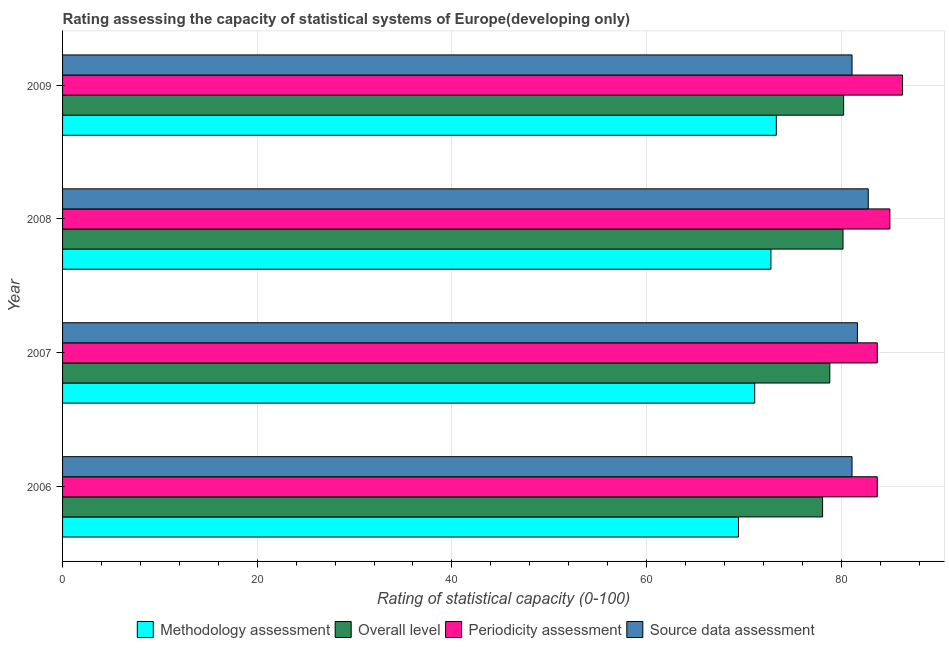How many groups of bars are there?
Keep it short and to the point. 4. How many bars are there on the 2nd tick from the top?
Your answer should be very brief. 4. How many bars are there on the 3rd tick from the bottom?
Provide a short and direct response. 4. What is the overall level rating in 2006?
Make the answer very short. 78.09. Across all years, what is the maximum periodicity assessment rating?
Your response must be concise. 86.3. Across all years, what is the minimum periodicity assessment rating?
Offer a terse response. 83.7. In which year was the source data assessment rating minimum?
Give a very brief answer. 2006. What is the total source data assessment rating in the graph?
Your response must be concise. 326.67. What is the difference between the periodicity assessment rating in 2008 and that in 2009?
Offer a very short reply. -1.3. What is the difference between the periodicity assessment rating in 2009 and the source data assessment rating in 2007?
Your answer should be very brief. 4.63. What is the average source data assessment rating per year?
Offer a very short reply. 81.67. In the year 2009, what is the difference between the methodology assessment rating and periodicity assessment rating?
Ensure brevity in your answer.  -12.96. What is the ratio of the periodicity assessment rating in 2006 to that in 2007?
Offer a very short reply. 1. Is the source data assessment rating in 2006 less than that in 2008?
Provide a succinct answer. Yes. Is the difference between the periodicity assessment rating in 2006 and 2007 greater than the difference between the overall level rating in 2006 and 2007?
Your answer should be very brief. Yes. What is the difference between the highest and the second highest source data assessment rating?
Provide a succinct answer. 1.11. What is the difference between the highest and the lowest periodicity assessment rating?
Provide a succinct answer. 2.59. Is the sum of the periodicity assessment rating in 2006 and 2009 greater than the maximum source data assessment rating across all years?
Keep it short and to the point. Yes. Is it the case that in every year, the sum of the periodicity assessment rating and source data assessment rating is greater than the sum of overall level rating and methodology assessment rating?
Provide a short and direct response. Yes. What does the 2nd bar from the top in 2009 represents?
Give a very brief answer. Periodicity assessment. What does the 2nd bar from the bottom in 2008 represents?
Give a very brief answer. Overall level. Is it the case that in every year, the sum of the methodology assessment rating and overall level rating is greater than the periodicity assessment rating?
Ensure brevity in your answer.  Yes. How many years are there in the graph?
Provide a short and direct response. 4. Are the values on the major ticks of X-axis written in scientific E-notation?
Provide a short and direct response. No. How many legend labels are there?
Keep it short and to the point. 4. What is the title of the graph?
Offer a terse response. Rating assessing the capacity of statistical systems of Europe(developing only). Does "UNTA" appear as one of the legend labels in the graph?
Offer a terse response. No. What is the label or title of the X-axis?
Give a very brief answer. Rating of statistical capacity (0-100). What is the label or title of the Y-axis?
Provide a succinct answer. Year. What is the Rating of statistical capacity (0-100) of Methodology assessment in 2006?
Your answer should be compact. 69.44. What is the Rating of statistical capacity (0-100) in Overall level in 2006?
Your response must be concise. 78.09. What is the Rating of statistical capacity (0-100) of Periodicity assessment in 2006?
Ensure brevity in your answer.  83.7. What is the Rating of statistical capacity (0-100) in Source data assessment in 2006?
Provide a short and direct response. 81.11. What is the Rating of statistical capacity (0-100) of Methodology assessment in 2007?
Give a very brief answer. 71.11. What is the Rating of statistical capacity (0-100) of Overall level in 2007?
Give a very brief answer. 78.83. What is the Rating of statistical capacity (0-100) in Periodicity assessment in 2007?
Ensure brevity in your answer.  83.7. What is the Rating of statistical capacity (0-100) of Source data assessment in 2007?
Offer a terse response. 81.67. What is the Rating of statistical capacity (0-100) in Methodology assessment in 2008?
Offer a terse response. 72.78. What is the Rating of statistical capacity (0-100) in Overall level in 2008?
Your answer should be compact. 80.19. What is the Rating of statistical capacity (0-100) of Periodicity assessment in 2008?
Give a very brief answer. 85. What is the Rating of statistical capacity (0-100) in Source data assessment in 2008?
Keep it short and to the point. 82.78. What is the Rating of statistical capacity (0-100) of Methodology assessment in 2009?
Your answer should be compact. 73.33. What is the Rating of statistical capacity (0-100) in Overall level in 2009?
Make the answer very short. 80.25. What is the Rating of statistical capacity (0-100) in Periodicity assessment in 2009?
Provide a succinct answer. 86.3. What is the Rating of statistical capacity (0-100) in Source data assessment in 2009?
Keep it short and to the point. 81.11. Across all years, what is the maximum Rating of statistical capacity (0-100) in Methodology assessment?
Give a very brief answer. 73.33. Across all years, what is the maximum Rating of statistical capacity (0-100) of Overall level?
Keep it short and to the point. 80.25. Across all years, what is the maximum Rating of statistical capacity (0-100) of Periodicity assessment?
Give a very brief answer. 86.3. Across all years, what is the maximum Rating of statistical capacity (0-100) in Source data assessment?
Keep it short and to the point. 82.78. Across all years, what is the minimum Rating of statistical capacity (0-100) of Methodology assessment?
Provide a succinct answer. 69.44. Across all years, what is the minimum Rating of statistical capacity (0-100) of Overall level?
Your answer should be compact. 78.09. Across all years, what is the minimum Rating of statistical capacity (0-100) of Periodicity assessment?
Offer a very short reply. 83.7. Across all years, what is the minimum Rating of statistical capacity (0-100) in Source data assessment?
Your answer should be very brief. 81.11. What is the total Rating of statistical capacity (0-100) of Methodology assessment in the graph?
Offer a terse response. 286.67. What is the total Rating of statistical capacity (0-100) of Overall level in the graph?
Offer a terse response. 317.35. What is the total Rating of statistical capacity (0-100) in Periodicity assessment in the graph?
Make the answer very short. 338.7. What is the total Rating of statistical capacity (0-100) of Source data assessment in the graph?
Make the answer very short. 326.67. What is the difference between the Rating of statistical capacity (0-100) in Methodology assessment in 2006 and that in 2007?
Provide a short and direct response. -1.67. What is the difference between the Rating of statistical capacity (0-100) of Overall level in 2006 and that in 2007?
Give a very brief answer. -0.74. What is the difference between the Rating of statistical capacity (0-100) of Source data assessment in 2006 and that in 2007?
Ensure brevity in your answer.  -0.56. What is the difference between the Rating of statistical capacity (0-100) of Overall level in 2006 and that in 2008?
Make the answer very short. -2.1. What is the difference between the Rating of statistical capacity (0-100) of Periodicity assessment in 2006 and that in 2008?
Your answer should be compact. -1.3. What is the difference between the Rating of statistical capacity (0-100) of Source data assessment in 2006 and that in 2008?
Make the answer very short. -1.67. What is the difference between the Rating of statistical capacity (0-100) in Methodology assessment in 2006 and that in 2009?
Give a very brief answer. -3.89. What is the difference between the Rating of statistical capacity (0-100) of Overall level in 2006 and that in 2009?
Your answer should be very brief. -2.16. What is the difference between the Rating of statistical capacity (0-100) of Periodicity assessment in 2006 and that in 2009?
Make the answer very short. -2.59. What is the difference between the Rating of statistical capacity (0-100) in Source data assessment in 2006 and that in 2009?
Your response must be concise. 0. What is the difference between the Rating of statistical capacity (0-100) of Methodology assessment in 2007 and that in 2008?
Offer a very short reply. -1.67. What is the difference between the Rating of statistical capacity (0-100) of Overall level in 2007 and that in 2008?
Ensure brevity in your answer.  -1.36. What is the difference between the Rating of statistical capacity (0-100) of Periodicity assessment in 2007 and that in 2008?
Keep it short and to the point. -1.3. What is the difference between the Rating of statistical capacity (0-100) in Source data assessment in 2007 and that in 2008?
Offer a terse response. -1.11. What is the difference between the Rating of statistical capacity (0-100) of Methodology assessment in 2007 and that in 2009?
Your response must be concise. -2.22. What is the difference between the Rating of statistical capacity (0-100) in Overall level in 2007 and that in 2009?
Offer a terse response. -1.42. What is the difference between the Rating of statistical capacity (0-100) of Periodicity assessment in 2007 and that in 2009?
Your response must be concise. -2.59. What is the difference between the Rating of statistical capacity (0-100) in Source data assessment in 2007 and that in 2009?
Give a very brief answer. 0.56. What is the difference between the Rating of statistical capacity (0-100) in Methodology assessment in 2008 and that in 2009?
Your answer should be very brief. -0.56. What is the difference between the Rating of statistical capacity (0-100) in Overall level in 2008 and that in 2009?
Offer a very short reply. -0.06. What is the difference between the Rating of statistical capacity (0-100) of Periodicity assessment in 2008 and that in 2009?
Provide a short and direct response. -1.3. What is the difference between the Rating of statistical capacity (0-100) in Source data assessment in 2008 and that in 2009?
Offer a very short reply. 1.67. What is the difference between the Rating of statistical capacity (0-100) in Methodology assessment in 2006 and the Rating of statistical capacity (0-100) in Overall level in 2007?
Give a very brief answer. -9.38. What is the difference between the Rating of statistical capacity (0-100) of Methodology assessment in 2006 and the Rating of statistical capacity (0-100) of Periodicity assessment in 2007?
Your response must be concise. -14.26. What is the difference between the Rating of statistical capacity (0-100) in Methodology assessment in 2006 and the Rating of statistical capacity (0-100) in Source data assessment in 2007?
Give a very brief answer. -12.22. What is the difference between the Rating of statistical capacity (0-100) in Overall level in 2006 and the Rating of statistical capacity (0-100) in Periodicity assessment in 2007?
Your answer should be very brief. -5.62. What is the difference between the Rating of statistical capacity (0-100) of Overall level in 2006 and the Rating of statistical capacity (0-100) of Source data assessment in 2007?
Ensure brevity in your answer.  -3.58. What is the difference between the Rating of statistical capacity (0-100) of Periodicity assessment in 2006 and the Rating of statistical capacity (0-100) of Source data assessment in 2007?
Ensure brevity in your answer.  2.04. What is the difference between the Rating of statistical capacity (0-100) in Methodology assessment in 2006 and the Rating of statistical capacity (0-100) in Overall level in 2008?
Keep it short and to the point. -10.74. What is the difference between the Rating of statistical capacity (0-100) in Methodology assessment in 2006 and the Rating of statistical capacity (0-100) in Periodicity assessment in 2008?
Provide a short and direct response. -15.56. What is the difference between the Rating of statistical capacity (0-100) of Methodology assessment in 2006 and the Rating of statistical capacity (0-100) of Source data assessment in 2008?
Ensure brevity in your answer.  -13.33. What is the difference between the Rating of statistical capacity (0-100) of Overall level in 2006 and the Rating of statistical capacity (0-100) of Periodicity assessment in 2008?
Your response must be concise. -6.91. What is the difference between the Rating of statistical capacity (0-100) of Overall level in 2006 and the Rating of statistical capacity (0-100) of Source data assessment in 2008?
Give a very brief answer. -4.69. What is the difference between the Rating of statistical capacity (0-100) of Periodicity assessment in 2006 and the Rating of statistical capacity (0-100) of Source data assessment in 2008?
Provide a short and direct response. 0.93. What is the difference between the Rating of statistical capacity (0-100) of Methodology assessment in 2006 and the Rating of statistical capacity (0-100) of Overall level in 2009?
Your answer should be very brief. -10.8. What is the difference between the Rating of statistical capacity (0-100) of Methodology assessment in 2006 and the Rating of statistical capacity (0-100) of Periodicity assessment in 2009?
Ensure brevity in your answer.  -16.85. What is the difference between the Rating of statistical capacity (0-100) of Methodology assessment in 2006 and the Rating of statistical capacity (0-100) of Source data assessment in 2009?
Provide a short and direct response. -11.67. What is the difference between the Rating of statistical capacity (0-100) of Overall level in 2006 and the Rating of statistical capacity (0-100) of Periodicity assessment in 2009?
Your answer should be very brief. -8.21. What is the difference between the Rating of statistical capacity (0-100) of Overall level in 2006 and the Rating of statistical capacity (0-100) of Source data assessment in 2009?
Offer a terse response. -3.02. What is the difference between the Rating of statistical capacity (0-100) of Periodicity assessment in 2006 and the Rating of statistical capacity (0-100) of Source data assessment in 2009?
Make the answer very short. 2.59. What is the difference between the Rating of statistical capacity (0-100) in Methodology assessment in 2007 and the Rating of statistical capacity (0-100) in Overall level in 2008?
Your answer should be very brief. -9.07. What is the difference between the Rating of statistical capacity (0-100) in Methodology assessment in 2007 and the Rating of statistical capacity (0-100) in Periodicity assessment in 2008?
Give a very brief answer. -13.89. What is the difference between the Rating of statistical capacity (0-100) in Methodology assessment in 2007 and the Rating of statistical capacity (0-100) in Source data assessment in 2008?
Your answer should be compact. -11.67. What is the difference between the Rating of statistical capacity (0-100) in Overall level in 2007 and the Rating of statistical capacity (0-100) in Periodicity assessment in 2008?
Your answer should be very brief. -6.17. What is the difference between the Rating of statistical capacity (0-100) in Overall level in 2007 and the Rating of statistical capacity (0-100) in Source data assessment in 2008?
Your answer should be very brief. -3.95. What is the difference between the Rating of statistical capacity (0-100) of Periodicity assessment in 2007 and the Rating of statistical capacity (0-100) of Source data assessment in 2008?
Provide a short and direct response. 0.93. What is the difference between the Rating of statistical capacity (0-100) of Methodology assessment in 2007 and the Rating of statistical capacity (0-100) of Overall level in 2009?
Your answer should be very brief. -9.14. What is the difference between the Rating of statistical capacity (0-100) in Methodology assessment in 2007 and the Rating of statistical capacity (0-100) in Periodicity assessment in 2009?
Provide a succinct answer. -15.18. What is the difference between the Rating of statistical capacity (0-100) of Overall level in 2007 and the Rating of statistical capacity (0-100) of Periodicity assessment in 2009?
Make the answer very short. -7.47. What is the difference between the Rating of statistical capacity (0-100) in Overall level in 2007 and the Rating of statistical capacity (0-100) in Source data assessment in 2009?
Provide a short and direct response. -2.28. What is the difference between the Rating of statistical capacity (0-100) in Periodicity assessment in 2007 and the Rating of statistical capacity (0-100) in Source data assessment in 2009?
Offer a very short reply. 2.59. What is the difference between the Rating of statistical capacity (0-100) of Methodology assessment in 2008 and the Rating of statistical capacity (0-100) of Overall level in 2009?
Keep it short and to the point. -7.47. What is the difference between the Rating of statistical capacity (0-100) of Methodology assessment in 2008 and the Rating of statistical capacity (0-100) of Periodicity assessment in 2009?
Provide a succinct answer. -13.52. What is the difference between the Rating of statistical capacity (0-100) in Methodology assessment in 2008 and the Rating of statistical capacity (0-100) in Source data assessment in 2009?
Your answer should be very brief. -8.33. What is the difference between the Rating of statistical capacity (0-100) in Overall level in 2008 and the Rating of statistical capacity (0-100) in Periodicity assessment in 2009?
Ensure brevity in your answer.  -6.11. What is the difference between the Rating of statistical capacity (0-100) of Overall level in 2008 and the Rating of statistical capacity (0-100) of Source data assessment in 2009?
Ensure brevity in your answer.  -0.93. What is the difference between the Rating of statistical capacity (0-100) of Periodicity assessment in 2008 and the Rating of statistical capacity (0-100) of Source data assessment in 2009?
Provide a succinct answer. 3.89. What is the average Rating of statistical capacity (0-100) in Methodology assessment per year?
Make the answer very short. 71.67. What is the average Rating of statistical capacity (0-100) in Overall level per year?
Make the answer very short. 79.34. What is the average Rating of statistical capacity (0-100) in Periodicity assessment per year?
Give a very brief answer. 84.68. What is the average Rating of statistical capacity (0-100) in Source data assessment per year?
Ensure brevity in your answer.  81.67. In the year 2006, what is the difference between the Rating of statistical capacity (0-100) in Methodology assessment and Rating of statistical capacity (0-100) in Overall level?
Your answer should be compact. -8.64. In the year 2006, what is the difference between the Rating of statistical capacity (0-100) of Methodology assessment and Rating of statistical capacity (0-100) of Periodicity assessment?
Ensure brevity in your answer.  -14.26. In the year 2006, what is the difference between the Rating of statistical capacity (0-100) in Methodology assessment and Rating of statistical capacity (0-100) in Source data assessment?
Provide a short and direct response. -11.67. In the year 2006, what is the difference between the Rating of statistical capacity (0-100) of Overall level and Rating of statistical capacity (0-100) of Periodicity assessment?
Give a very brief answer. -5.62. In the year 2006, what is the difference between the Rating of statistical capacity (0-100) in Overall level and Rating of statistical capacity (0-100) in Source data assessment?
Keep it short and to the point. -3.02. In the year 2006, what is the difference between the Rating of statistical capacity (0-100) in Periodicity assessment and Rating of statistical capacity (0-100) in Source data assessment?
Keep it short and to the point. 2.59. In the year 2007, what is the difference between the Rating of statistical capacity (0-100) in Methodology assessment and Rating of statistical capacity (0-100) in Overall level?
Your answer should be very brief. -7.72. In the year 2007, what is the difference between the Rating of statistical capacity (0-100) of Methodology assessment and Rating of statistical capacity (0-100) of Periodicity assessment?
Your answer should be compact. -12.59. In the year 2007, what is the difference between the Rating of statistical capacity (0-100) in Methodology assessment and Rating of statistical capacity (0-100) in Source data assessment?
Provide a short and direct response. -10.56. In the year 2007, what is the difference between the Rating of statistical capacity (0-100) in Overall level and Rating of statistical capacity (0-100) in Periodicity assessment?
Your answer should be very brief. -4.88. In the year 2007, what is the difference between the Rating of statistical capacity (0-100) in Overall level and Rating of statistical capacity (0-100) in Source data assessment?
Your answer should be very brief. -2.84. In the year 2007, what is the difference between the Rating of statistical capacity (0-100) in Periodicity assessment and Rating of statistical capacity (0-100) in Source data assessment?
Provide a succinct answer. 2.04. In the year 2008, what is the difference between the Rating of statistical capacity (0-100) in Methodology assessment and Rating of statistical capacity (0-100) in Overall level?
Your answer should be very brief. -7.41. In the year 2008, what is the difference between the Rating of statistical capacity (0-100) of Methodology assessment and Rating of statistical capacity (0-100) of Periodicity assessment?
Your answer should be compact. -12.22. In the year 2008, what is the difference between the Rating of statistical capacity (0-100) in Methodology assessment and Rating of statistical capacity (0-100) in Source data assessment?
Ensure brevity in your answer.  -10. In the year 2008, what is the difference between the Rating of statistical capacity (0-100) of Overall level and Rating of statistical capacity (0-100) of Periodicity assessment?
Offer a terse response. -4.81. In the year 2008, what is the difference between the Rating of statistical capacity (0-100) of Overall level and Rating of statistical capacity (0-100) of Source data assessment?
Ensure brevity in your answer.  -2.59. In the year 2008, what is the difference between the Rating of statistical capacity (0-100) of Periodicity assessment and Rating of statistical capacity (0-100) of Source data assessment?
Give a very brief answer. 2.22. In the year 2009, what is the difference between the Rating of statistical capacity (0-100) of Methodology assessment and Rating of statistical capacity (0-100) of Overall level?
Provide a succinct answer. -6.91. In the year 2009, what is the difference between the Rating of statistical capacity (0-100) in Methodology assessment and Rating of statistical capacity (0-100) in Periodicity assessment?
Your response must be concise. -12.96. In the year 2009, what is the difference between the Rating of statistical capacity (0-100) in Methodology assessment and Rating of statistical capacity (0-100) in Source data assessment?
Your answer should be compact. -7.78. In the year 2009, what is the difference between the Rating of statistical capacity (0-100) of Overall level and Rating of statistical capacity (0-100) of Periodicity assessment?
Give a very brief answer. -6.05. In the year 2009, what is the difference between the Rating of statistical capacity (0-100) of Overall level and Rating of statistical capacity (0-100) of Source data assessment?
Offer a very short reply. -0.86. In the year 2009, what is the difference between the Rating of statistical capacity (0-100) of Periodicity assessment and Rating of statistical capacity (0-100) of Source data assessment?
Offer a terse response. 5.18. What is the ratio of the Rating of statistical capacity (0-100) of Methodology assessment in 2006 to that in 2007?
Your response must be concise. 0.98. What is the ratio of the Rating of statistical capacity (0-100) of Overall level in 2006 to that in 2007?
Ensure brevity in your answer.  0.99. What is the ratio of the Rating of statistical capacity (0-100) in Methodology assessment in 2006 to that in 2008?
Offer a very short reply. 0.95. What is the ratio of the Rating of statistical capacity (0-100) of Overall level in 2006 to that in 2008?
Make the answer very short. 0.97. What is the ratio of the Rating of statistical capacity (0-100) in Periodicity assessment in 2006 to that in 2008?
Keep it short and to the point. 0.98. What is the ratio of the Rating of statistical capacity (0-100) in Source data assessment in 2006 to that in 2008?
Ensure brevity in your answer.  0.98. What is the ratio of the Rating of statistical capacity (0-100) in Methodology assessment in 2006 to that in 2009?
Your response must be concise. 0.95. What is the ratio of the Rating of statistical capacity (0-100) in Overall level in 2006 to that in 2009?
Offer a very short reply. 0.97. What is the ratio of the Rating of statistical capacity (0-100) in Periodicity assessment in 2006 to that in 2009?
Provide a short and direct response. 0.97. What is the ratio of the Rating of statistical capacity (0-100) of Methodology assessment in 2007 to that in 2008?
Your answer should be compact. 0.98. What is the ratio of the Rating of statistical capacity (0-100) of Overall level in 2007 to that in 2008?
Offer a terse response. 0.98. What is the ratio of the Rating of statistical capacity (0-100) in Periodicity assessment in 2007 to that in 2008?
Offer a very short reply. 0.98. What is the ratio of the Rating of statistical capacity (0-100) in Source data assessment in 2007 to that in 2008?
Ensure brevity in your answer.  0.99. What is the ratio of the Rating of statistical capacity (0-100) in Methodology assessment in 2007 to that in 2009?
Your answer should be compact. 0.97. What is the ratio of the Rating of statistical capacity (0-100) of Overall level in 2007 to that in 2009?
Keep it short and to the point. 0.98. What is the ratio of the Rating of statistical capacity (0-100) of Periodicity assessment in 2007 to that in 2009?
Make the answer very short. 0.97. What is the ratio of the Rating of statistical capacity (0-100) of Source data assessment in 2007 to that in 2009?
Your answer should be compact. 1.01. What is the ratio of the Rating of statistical capacity (0-100) in Methodology assessment in 2008 to that in 2009?
Offer a terse response. 0.99. What is the ratio of the Rating of statistical capacity (0-100) of Overall level in 2008 to that in 2009?
Your answer should be compact. 1. What is the ratio of the Rating of statistical capacity (0-100) of Source data assessment in 2008 to that in 2009?
Make the answer very short. 1.02. What is the difference between the highest and the second highest Rating of statistical capacity (0-100) of Methodology assessment?
Make the answer very short. 0.56. What is the difference between the highest and the second highest Rating of statistical capacity (0-100) of Overall level?
Offer a very short reply. 0.06. What is the difference between the highest and the second highest Rating of statistical capacity (0-100) in Periodicity assessment?
Ensure brevity in your answer.  1.3. What is the difference between the highest and the lowest Rating of statistical capacity (0-100) in Methodology assessment?
Provide a succinct answer. 3.89. What is the difference between the highest and the lowest Rating of statistical capacity (0-100) in Overall level?
Offer a very short reply. 2.16. What is the difference between the highest and the lowest Rating of statistical capacity (0-100) of Periodicity assessment?
Offer a terse response. 2.59. What is the difference between the highest and the lowest Rating of statistical capacity (0-100) in Source data assessment?
Offer a terse response. 1.67. 